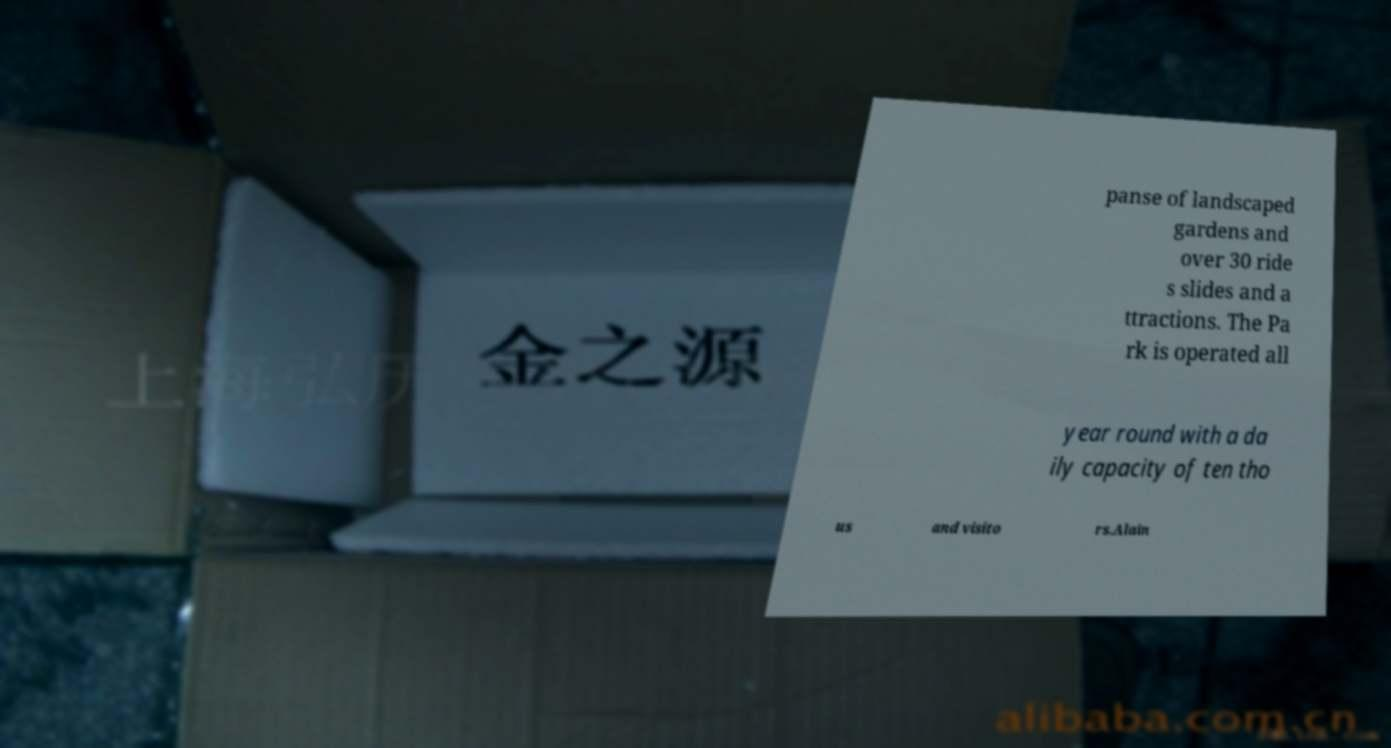There's text embedded in this image that I need extracted. Can you transcribe it verbatim? panse of landscaped gardens and over 30 ride s slides and a ttractions. The Pa rk is operated all year round with a da ily capacity of ten tho us and visito rs.Alain 